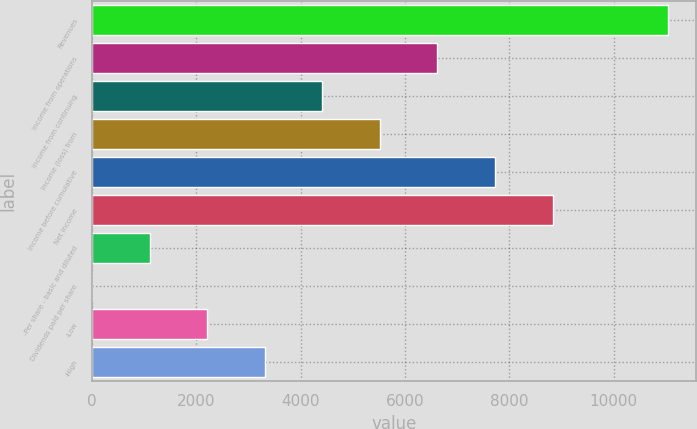<chart> <loc_0><loc_0><loc_500><loc_500><bar_chart><fcel>Revenues<fcel>Income from operations<fcel>Income from continuing<fcel>Income (loss) from<fcel>Income before cumulative<fcel>Net income<fcel>-Per share - basic and diluted<fcel>Dividends paid per share<fcel>-Low<fcel>-High<nl><fcel>11034<fcel>6620.48<fcel>4413.74<fcel>5517.11<fcel>7723.85<fcel>8827.23<fcel>1103.62<fcel>0.25<fcel>2206.99<fcel>3310.36<nl></chart> 